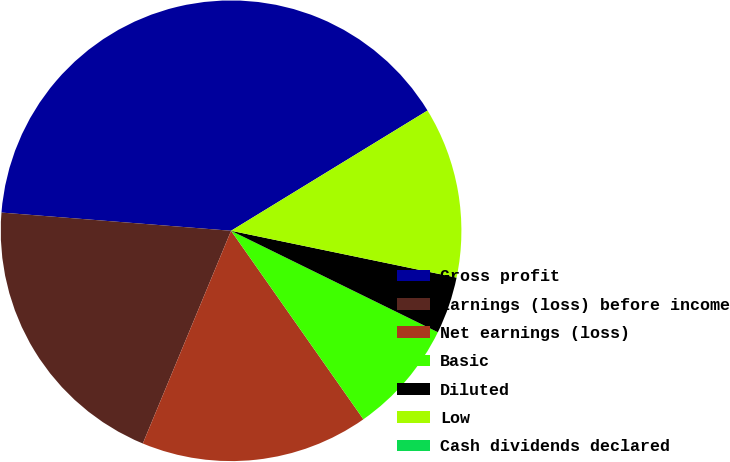<chart> <loc_0><loc_0><loc_500><loc_500><pie_chart><fcel>Gross profit<fcel>Earnings (loss) before income<fcel>Net earnings (loss)<fcel>Basic<fcel>Diluted<fcel>Low<fcel>Cash dividends declared<nl><fcel>40.0%<fcel>20.0%<fcel>16.0%<fcel>8.0%<fcel>4.0%<fcel>12.0%<fcel>0.0%<nl></chart> 